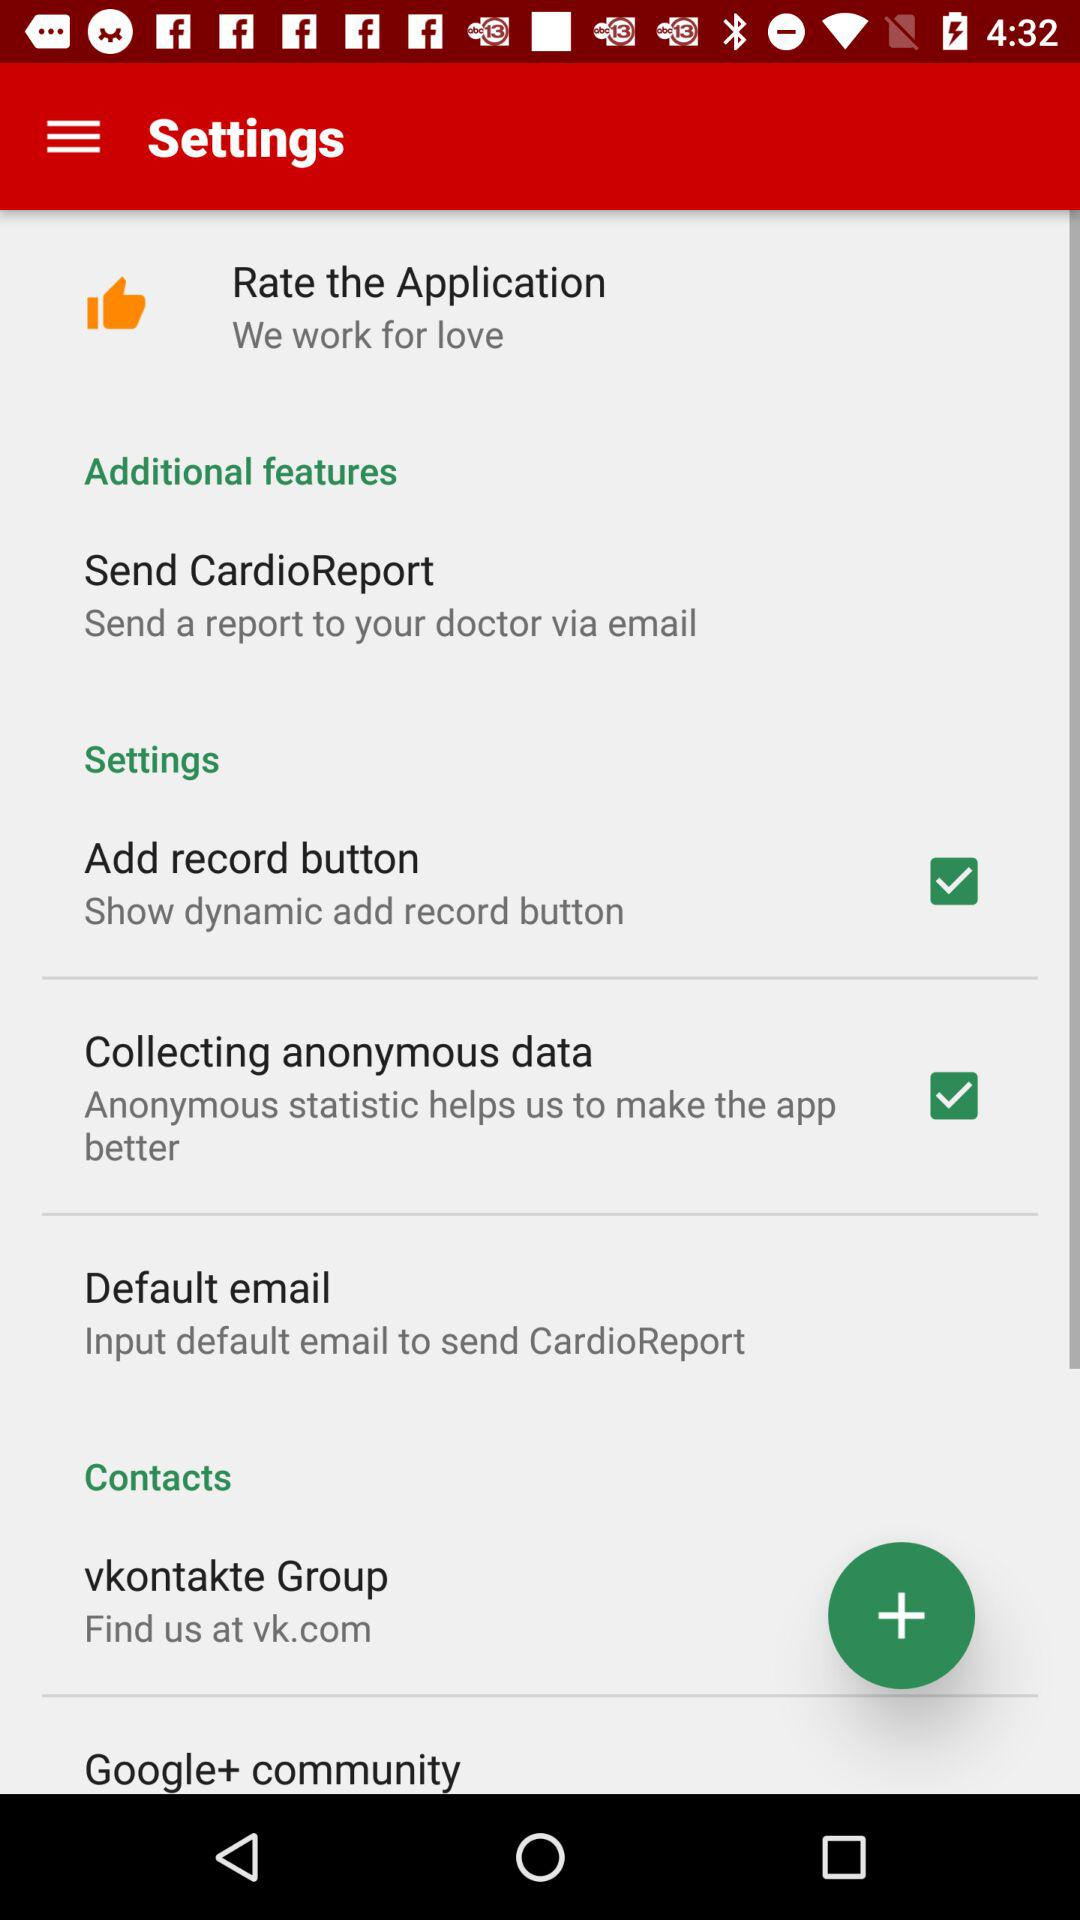What is the status of "Add record button"? The status is "on". 